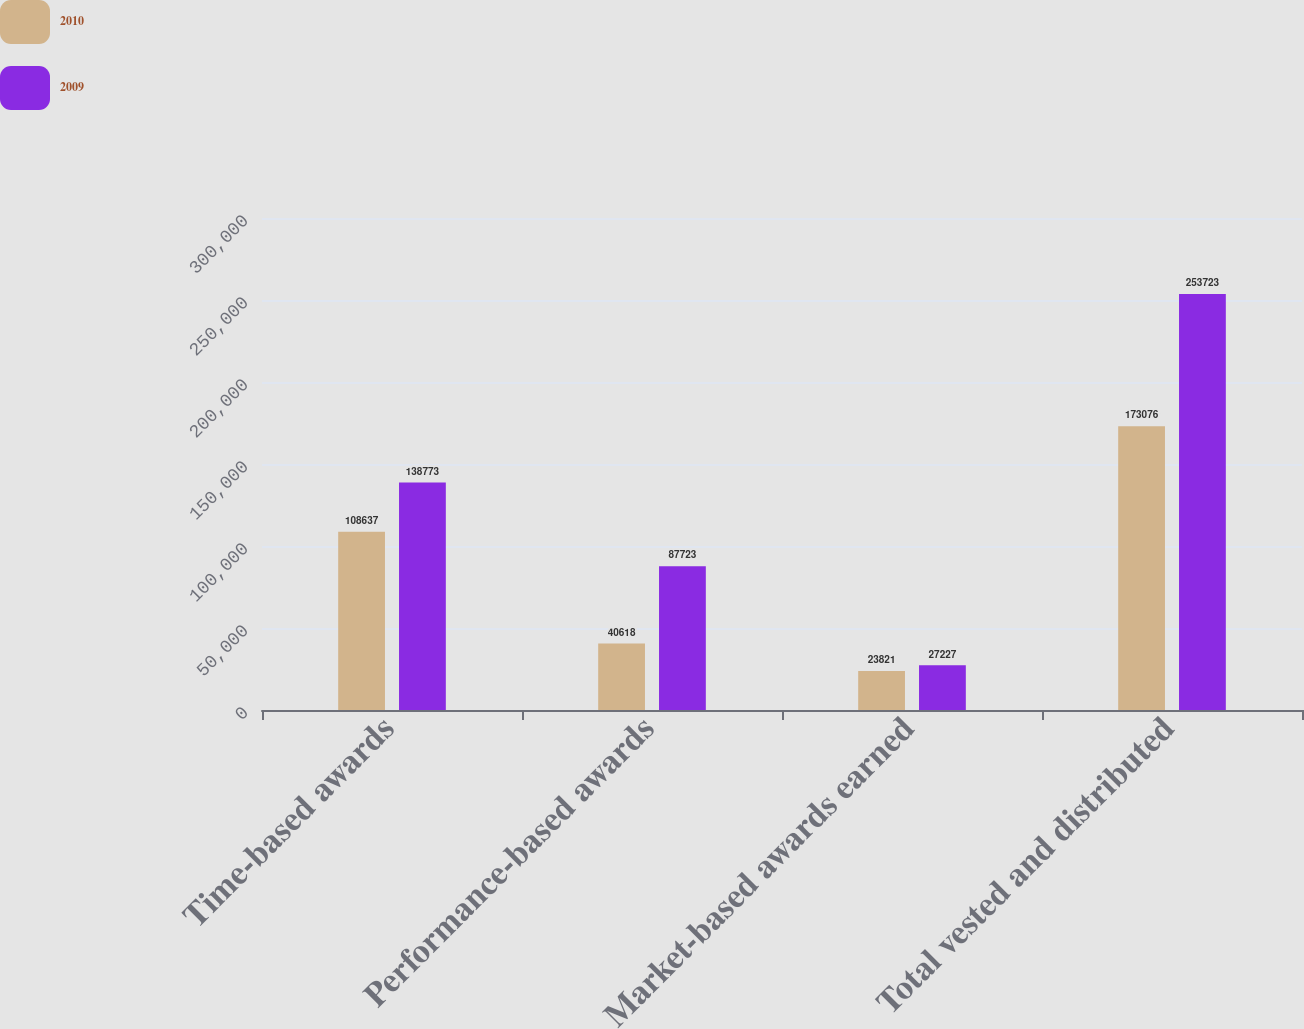Convert chart. <chart><loc_0><loc_0><loc_500><loc_500><stacked_bar_chart><ecel><fcel>Time-based awards<fcel>Performance-based awards<fcel>Market-based awards earned<fcel>Total vested and distributed<nl><fcel>2010<fcel>108637<fcel>40618<fcel>23821<fcel>173076<nl><fcel>2009<fcel>138773<fcel>87723<fcel>27227<fcel>253723<nl></chart> 